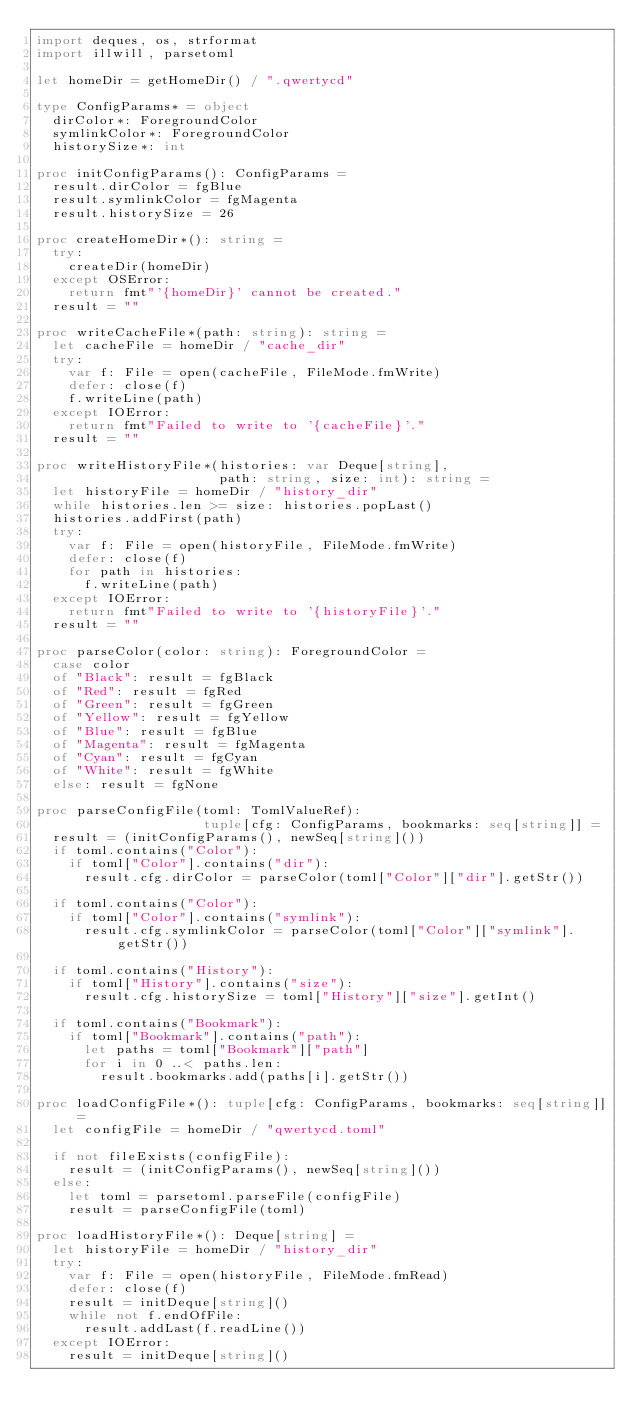Convert code to text. <code><loc_0><loc_0><loc_500><loc_500><_Nim_>import deques, os, strformat
import illwill, parsetoml

let homeDir = getHomeDir() / ".qwertycd"

type ConfigParams* = object
  dirColor*: ForegroundColor
  symlinkColor*: ForegroundColor
  historySize*: int

proc initConfigParams(): ConfigParams =
  result.dirColor = fgBlue
  result.symlinkColor = fgMagenta
  result.historySize = 26

proc createHomeDir*(): string =
  try:
    createDir(homeDir)
  except OSError:
    return fmt"'{homeDir}' cannot be created."
  result = ""

proc writeCacheFile*(path: string): string =
  let cacheFile = homeDir / "cache_dir"
  try:
    var f: File = open(cacheFile, FileMode.fmWrite)
    defer: close(f)
    f.writeLine(path)
  except IOError:
    return fmt"Failed to write to '{cacheFile}'."
  result = ""

proc writeHistoryFile*(histories: var Deque[string],
                       path: string, size: int): string =
  let historyFile = homeDir / "history_dir"
  while histories.len >= size: histories.popLast()
  histories.addFirst(path)
  try:
    var f: File = open(historyFile, FileMode.fmWrite)
    defer: close(f)
    for path in histories:
      f.writeLine(path)
  except IOError:
    return fmt"Failed to write to '{historyFile}'."
  result = ""

proc parseColor(color: string): ForegroundColor =
  case color
  of "Black": result = fgBlack
  of "Red": result = fgRed
  of "Green": result = fgGreen
  of "Yellow": result = fgYellow
  of "Blue": result = fgBlue
  of "Magenta": result = fgMagenta
  of "Cyan": result = fgCyan
  of "White": result = fgWhite
  else: result = fgNone

proc parseConfigFile(toml: TomlValueRef):
                     tuple[cfg: ConfigParams, bookmarks: seq[string]] =
  result = (initConfigParams(), newSeq[string]())
  if toml.contains("Color"):
    if toml["Color"].contains("dir"):
      result.cfg.dirColor = parseColor(toml["Color"]["dir"].getStr())

  if toml.contains("Color"):
    if toml["Color"].contains("symlink"):
      result.cfg.symlinkColor = parseColor(toml["Color"]["symlink"].getStr())

  if toml.contains("History"):
    if toml["History"].contains("size"):
      result.cfg.historySize = toml["History"]["size"].getInt()

  if toml.contains("Bookmark"):
    if toml["Bookmark"].contains("path"):
      let paths = toml["Bookmark"]["path"]
      for i in 0 ..< paths.len:
        result.bookmarks.add(paths[i].getStr())

proc loadConfigFile*(): tuple[cfg: ConfigParams, bookmarks: seq[string]] =
  let configFile = homeDir / "qwertycd.toml"

  if not fileExists(configFile):
    result = (initConfigParams(), newSeq[string]())
  else:
    let toml = parsetoml.parseFile(configFile)
    result = parseConfigFile(toml)

proc loadHistoryFile*(): Deque[string] =
  let historyFile = homeDir / "history_dir"
  try:
    var f: File = open(historyFile, FileMode.fmRead)
    defer: close(f)
    result = initDeque[string]()
    while not f.endOfFile:
      result.addLast(f.readLine())
  except IOError:
    result = initDeque[string]()
</code> 